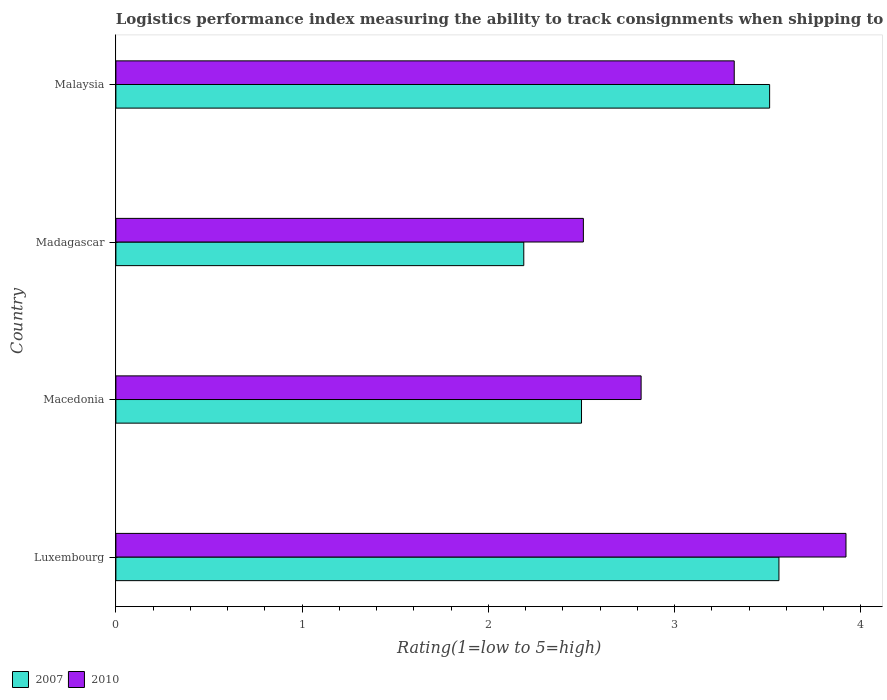How many groups of bars are there?
Make the answer very short. 4. Are the number of bars on each tick of the Y-axis equal?
Keep it short and to the point. Yes. How many bars are there on the 3rd tick from the bottom?
Provide a short and direct response. 2. What is the label of the 3rd group of bars from the top?
Ensure brevity in your answer.  Macedonia. In how many cases, is the number of bars for a given country not equal to the number of legend labels?
Offer a terse response. 0. What is the Logistic performance index in 2010 in Malaysia?
Provide a short and direct response. 3.32. Across all countries, what is the maximum Logistic performance index in 2007?
Your answer should be very brief. 3.56. Across all countries, what is the minimum Logistic performance index in 2010?
Your answer should be very brief. 2.51. In which country was the Logistic performance index in 2007 maximum?
Offer a very short reply. Luxembourg. In which country was the Logistic performance index in 2007 minimum?
Your response must be concise. Madagascar. What is the total Logistic performance index in 2010 in the graph?
Give a very brief answer. 12.57. What is the difference between the Logistic performance index in 2010 in Madagascar and that in Malaysia?
Give a very brief answer. -0.81. What is the difference between the Logistic performance index in 2010 in Macedonia and the Logistic performance index in 2007 in Malaysia?
Make the answer very short. -0.69. What is the average Logistic performance index in 2007 per country?
Offer a terse response. 2.94. What is the difference between the Logistic performance index in 2010 and Logistic performance index in 2007 in Malaysia?
Your answer should be compact. -0.19. In how many countries, is the Logistic performance index in 2010 greater than 1.2 ?
Make the answer very short. 4. What is the ratio of the Logistic performance index in 2010 in Luxembourg to that in Macedonia?
Your response must be concise. 1.39. What is the difference between the highest and the second highest Logistic performance index in 2010?
Offer a terse response. 0.6. What is the difference between the highest and the lowest Logistic performance index in 2010?
Your answer should be compact. 1.41. Is the sum of the Logistic performance index in 2010 in Luxembourg and Macedonia greater than the maximum Logistic performance index in 2007 across all countries?
Your answer should be very brief. Yes. What does the 2nd bar from the top in Malaysia represents?
Provide a short and direct response. 2007. What does the 1st bar from the bottom in Madagascar represents?
Offer a terse response. 2007. How many bars are there?
Provide a succinct answer. 8. What is the difference between two consecutive major ticks on the X-axis?
Your response must be concise. 1. Does the graph contain grids?
Provide a succinct answer. No. What is the title of the graph?
Make the answer very short. Logistics performance index measuring the ability to track consignments when shipping to a market. What is the label or title of the X-axis?
Your response must be concise. Rating(1=low to 5=high). What is the label or title of the Y-axis?
Ensure brevity in your answer.  Country. What is the Rating(1=low to 5=high) of 2007 in Luxembourg?
Provide a succinct answer. 3.56. What is the Rating(1=low to 5=high) in 2010 in Luxembourg?
Your answer should be very brief. 3.92. What is the Rating(1=low to 5=high) in 2010 in Macedonia?
Provide a short and direct response. 2.82. What is the Rating(1=low to 5=high) in 2007 in Madagascar?
Provide a short and direct response. 2.19. What is the Rating(1=low to 5=high) in 2010 in Madagascar?
Your answer should be very brief. 2.51. What is the Rating(1=low to 5=high) in 2007 in Malaysia?
Provide a short and direct response. 3.51. What is the Rating(1=low to 5=high) in 2010 in Malaysia?
Your answer should be very brief. 3.32. Across all countries, what is the maximum Rating(1=low to 5=high) of 2007?
Your answer should be compact. 3.56. Across all countries, what is the maximum Rating(1=low to 5=high) in 2010?
Offer a terse response. 3.92. Across all countries, what is the minimum Rating(1=low to 5=high) of 2007?
Give a very brief answer. 2.19. Across all countries, what is the minimum Rating(1=low to 5=high) in 2010?
Give a very brief answer. 2.51. What is the total Rating(1=low to 5=high) of 2007 in the graph?
Ensure brevity in your answer.  11.76. What is the total Rating(1=low to 5=high) in 2010 in the graph?
Provide a succinct answer. 12.57. What is the difference between the Rating(1=low to 5=high) in 2007 in Luxembourg and that in Macedonia?
Keep it short and to the point. 1.06. What is the difference between the Rating(1=low to 5=high) in 2010 in Luxembourg and that in Macedonia?
Provide a short and direct response. 1.1. What is the difference between the Rating(1=low to 5=high) in 2007 in Luxembourg and that in Madagascar?
Keep it short and to the point. 1.37. What is the difference between the Rating(1=low to 5=high) in 2010 in Luxembourg and that in Madagascar?
Give a very brief answer. 1.41. What is the difference between the Rating(1=low to 5=high) of 2007 in Luxembourg and that in Malaysia?
Give a very brief answer. 0.05. What is the difference between the Rating(1=low to 5=high) in 2010 in Luxembourg and that in Malaysia?
Make the answer very short. 0.6. What is the difference between the Rating(1=low to 5=high) of 2007 in Macedonia and that in Madagascar?
Make the answer very short. 0.31. What is the difference between the Rating(1=low to 5=high) in 2010 in Macedonia and that in Madagascar?
Provide a succinct answer. 0.31. What is the difference between the Rating(1=low to 5=high) in 2007 in Macedonia and that in Malaysia?
Provide a short and direct response. -1.01. What is the difference between the Rating(1=low to 5=high) in 2010 in Macedonia and that in Malaysia?
Your response must be concise. -0.5. What is the difference between the Rating(1=low to 5=high) of 2007 in Madagascar and that in Malaysia?
Your answer should be compact. -1.32. What is the difference between the Rating(1=low to 5=high) in 2010 in Madagascar and that in Malaysia?
Give a very brief answer. -0.81. What is the difference between the Rating(1=low to 5=high) in 2007 in Luxembourg and the Rating(1=low to 5=high) in 2010 in Macedonia?
Provide a short and direct response. 0.74. What is the difference between the Rating(1=low to 5=high) in 2007 in Luxembourg and the Rating(1=low to 5=high) in 2010 in Madagascar?
Ensure brevity in your answer.  1.05. What is the difference between the Rating(1=low to 5=high) of 2007 in Luxembourg and the Rating(1=low to 5=high) of 2010 in Malaysia?
Make the answer very short. 0.24. What is the difference between the Rating(1=low to 5=high) of 2007 in Macedonia and the Rating(1=low to 5=high) of 2010 in Madagascar?
Offer a terse response. -0.01. What is the difference between the Rating(1=low to 5=high) of 2007 in Macedonia and the Rating(1=low to 5=high) of 2010 in Malaysia?
Your answer should be compact. -0.82. What is the difference between the Rating(1=low to 5=high) in 2007 in Madagascar and the Rating(1=low to 5=high) in 2010 in Malaysia?
Ensure brevity in your answer.  -1.13. What is the average Rating(1=low to 5=high) of 2007 per country?
Offer a very short reply. 2.94. What is the average Rating(1=low to 5=high) of 2010 per country?
Your response must be concise. 3.14. What is the difference between the Rating(1=low to 5=high) in 2007 and Rating(1=low to 5=high) in 2010 in Luxembourg?
Make the answer very short. -0.36. What is the difference between the Rating(1=low to 5=high) in 2007 and Rating(1=low to 5=high) in 2010 in Macedonia?
Offer a terse response. -0.32. What is the difference between the Rating(1=low to 5=high) in 2007 and Rating(1=low to 5=high) in 2010 in Madagascar?
Your answer should be very brief. -0.32. What is the difference between the Rating(1=low to 5=high) of 2007 and Rating(1=low to 5=high) of 2010 in Malaysia?
Provide a short and direct response. 0.19. What is the ratio of the Rating(1=low to 5=high) in 2007 in Luxembourg to that in Macedonia?
Provide a succinct answer. 1.42. What is the ratio of the Rating(1=low to 5=high) of 2010 in Luxembourg to that in Macedonia?
Your answer should be very brief. 1.39. What is the ratio of the Rating(1=low to 5=high) of 2007 in Luxembourg to that in Madagascar?
Make the answer very short. 1.63. What is the ratio of the Rating(1=low to 5=high) of 2010 in Luxembourg to that in Madagascar?
Provide a short and direct response. 1.56. What is the ratio of the Rating(1=low to 5=high) of 2007 in Luxembourg to that in Malaysia?
Ensure brevity in your answer.  1.01. What is the ratio of the Rating(1=low to 5=high) in 2010 in Luxembourg to that in Malaysia?
Give a very brief answer. 1.18. What is the ratio of the Rating(1=low to 5=high) of 2007 in Macedonia to that in Madagascar?
Offer a very short reply. 1.14. What is the ratio of the Rating(1=low to 5=high) of 2010 in Macedonia to that in Madagascar?
Offer a terse response. 1.12. What is the ratio of the Rating(1=low to 5=high) of 2007 in Macedonia to that in Malaysia?
Ensure brevity in your answer.  0.71. What is the ratio of the Rating(1=low to 5=high) in 2010 in Macedonia to that in Malaysia?
Ensure brevity in your answer.  0.85. What is the ratio of the Rating(1=low to 5=high) of 2007 in Madagascar to that in Malaysia?
Offer a very short reply. 0.62. What is the ratio of the Rating(1=low to 5=high) in 2010 in Madagascar to that in Malaysia?
Provide a short and direct response. 0.76. What is the difference between the highest and the second highest Rating(1=low to 5=high) in 2007?
Your response must be concise. 0.05. What is the difference between the highest and the lowest Rating(1=low to 5=high) of 2007?
Make the answer very short. 1.37. What is the difference between the highest and the lowest Rating(1=low to 5=high) in 2010?
Your answer should be compact. 1.41. 